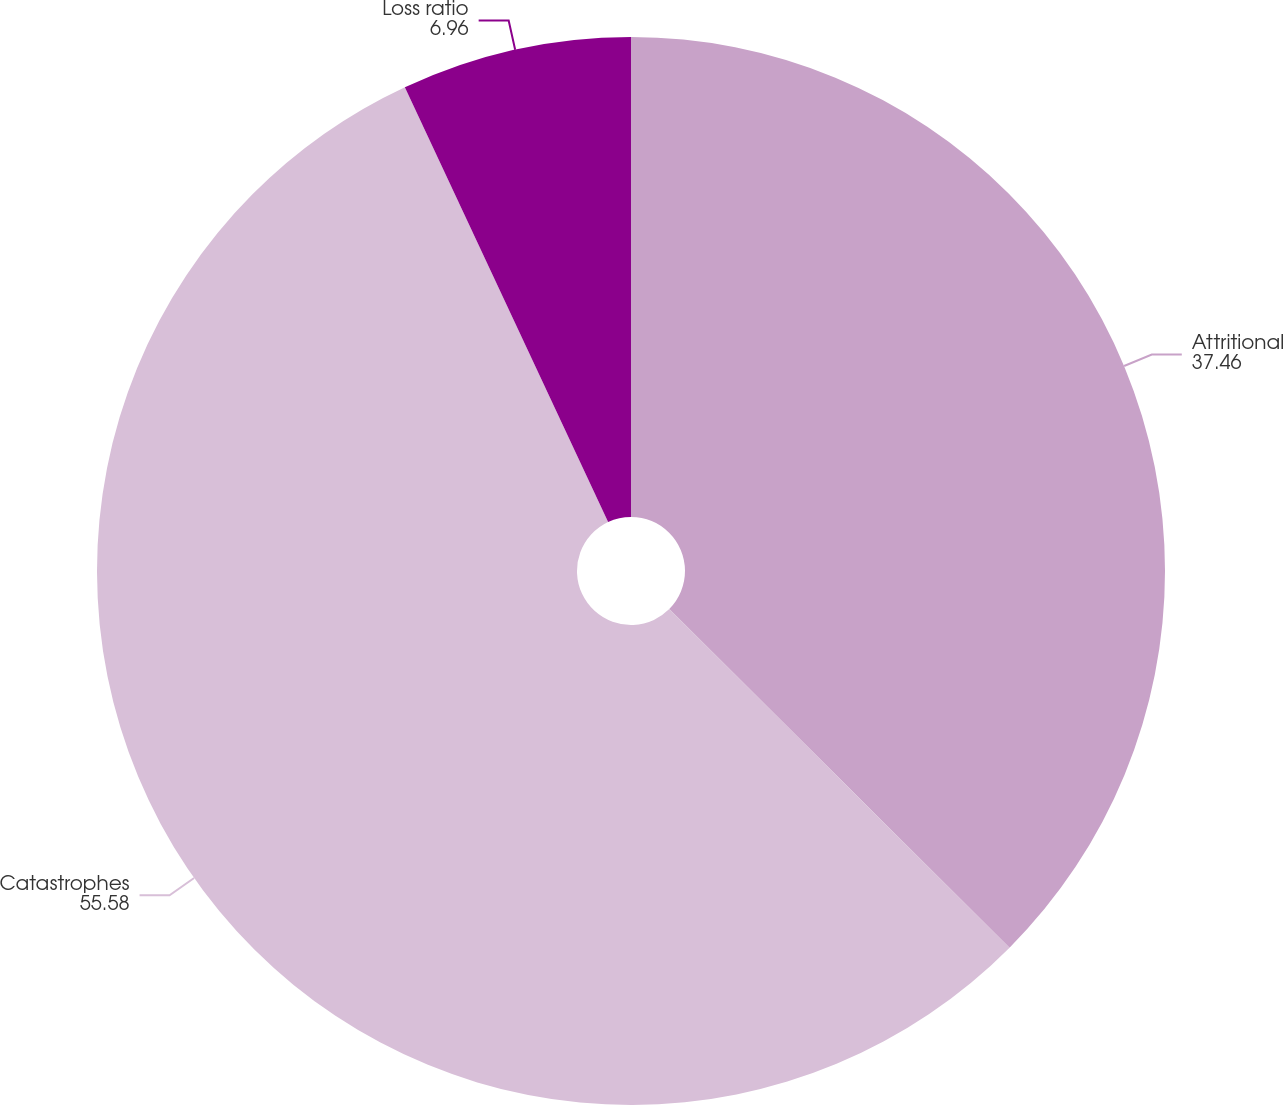<chart> <loc_0><loc_0><loc_500><loc_500><pie_chart><fcel>Attritional<fcel>Catastrophes<fcel>Loss ratio<nl><fcel>37.46%<fcel>55.58%<fcel>6.96%<nl></chart> 